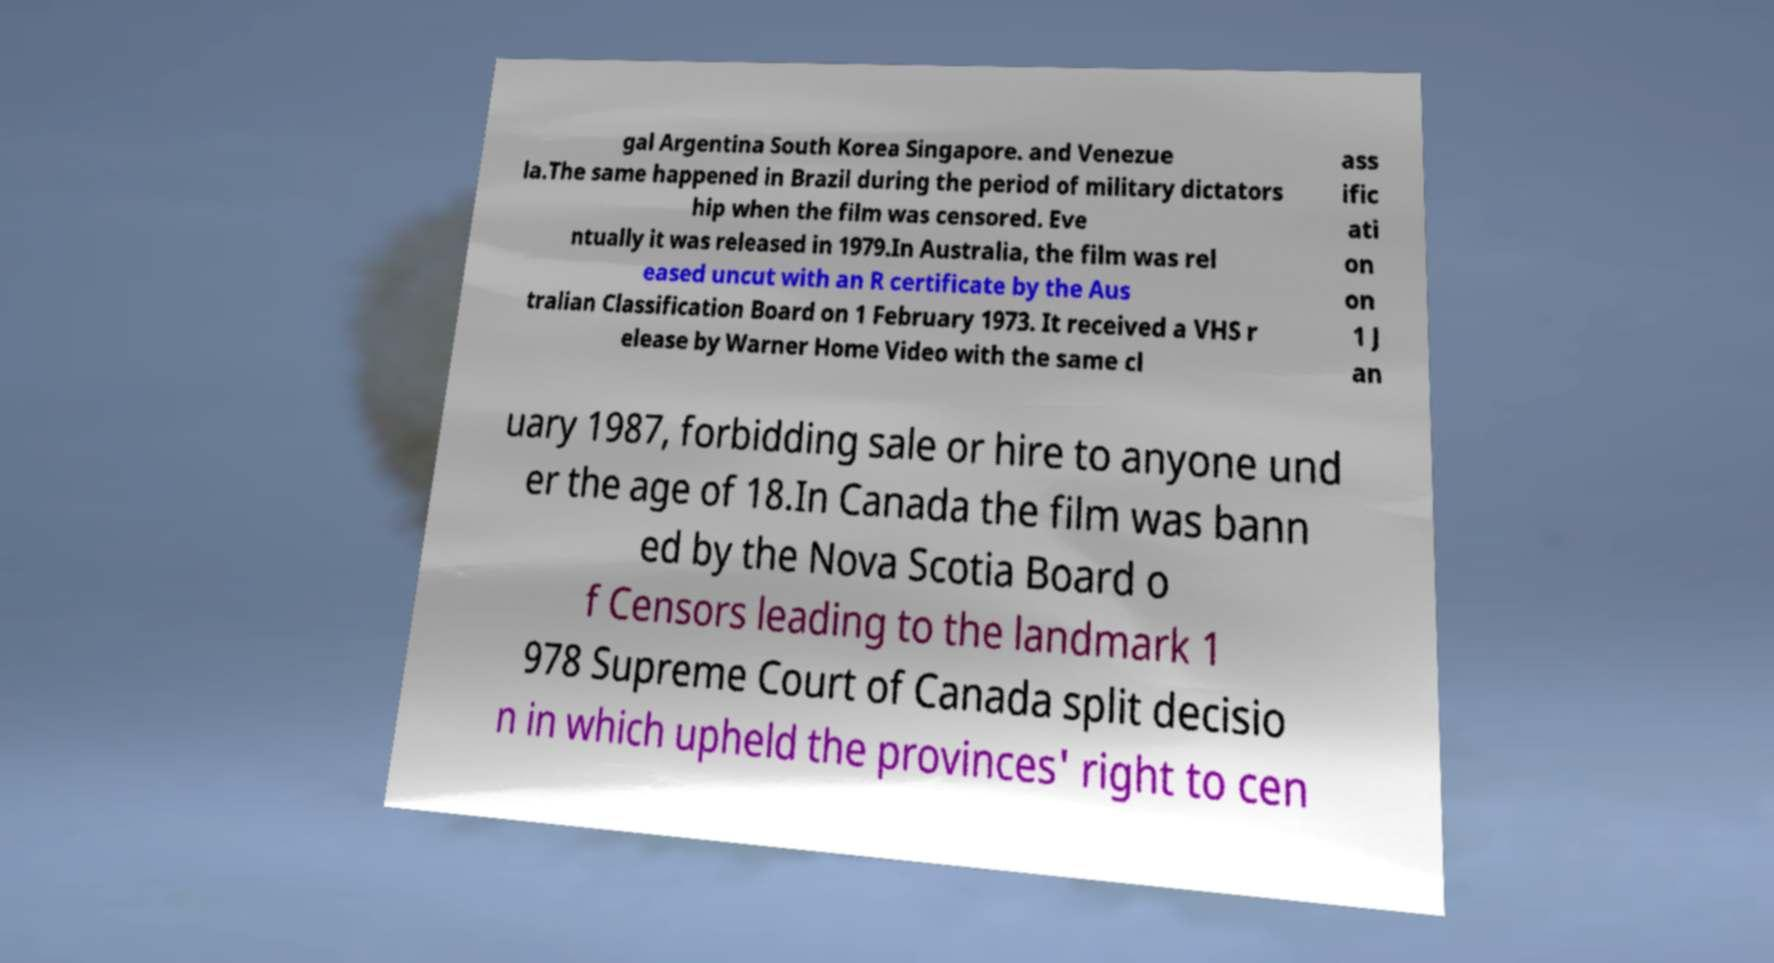Could you assist in decoding the text presented in this image and type it out clearly? gal Argentina South Korea Singapore. and Venezue la.The same happened in Brazil during the period of military dictators hip when the film was censored. Eve ntually it was released in 1979.In Australia, the film was rel eased uncut with an R certificate by the Aus tralian Classification Board on 1 February 1973. It received a VHS r elease by Warner Home Video with the same cl ass ific ati on on 1 J an uary 1987, forbidding sale or hire to anyone und er the age of 18.In Canada the film was bann ed by the Nova Scotia Board o f Censors leading to the landmark 1 978 Supreme Court of Canada split decisio n in which upheld the provinces' right to cen 